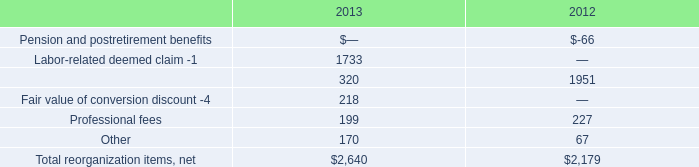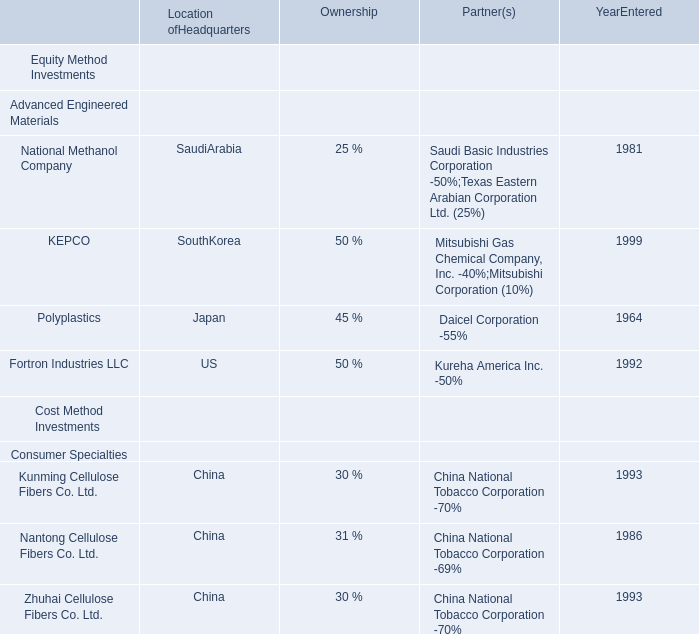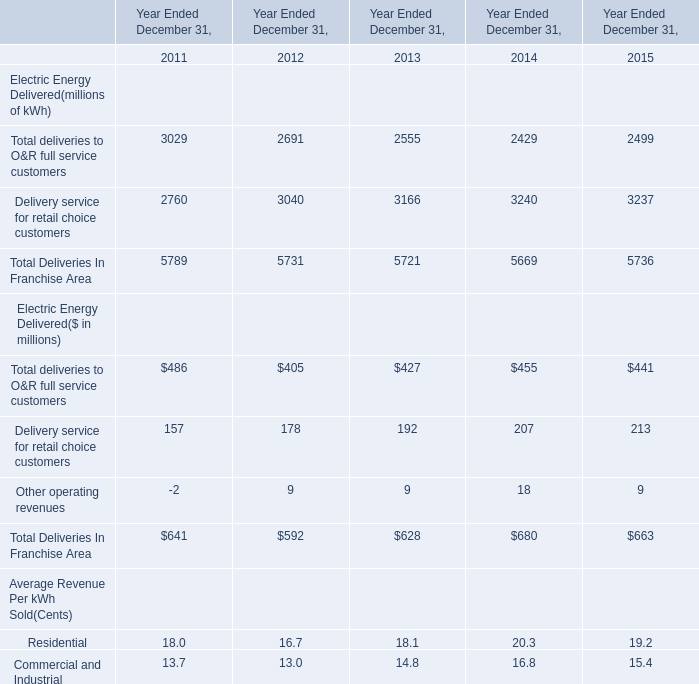in 2013 what was the ratio of the interest expense , net of capitalized interest to the other non operating income net related to debt extinguishm net and currency losses 
Computations: (710 / 84)
Answer: 8.45238. 